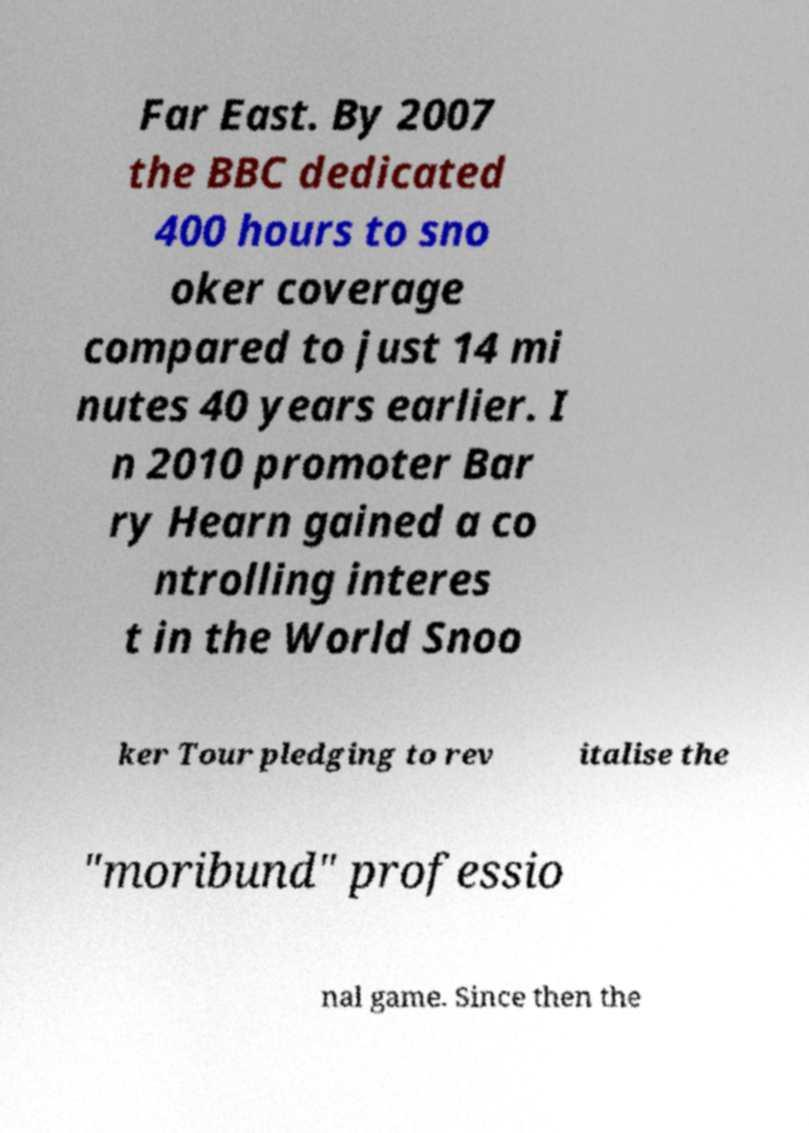Can you accurately transcribe the text from the provided image for me? Far East. By 2007 the BBC dedicated 400 hours to sno oker coverage compared to just 14 mi nutes 40 years earlier. I n 2010 promoter Bar ry Hearn gained a co ntrolling interes t in the World Snoo ker Tour pledging to rev italise the "moribund" professio nal game. Since then the 